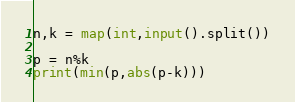Convert code to text. <code><loc_0><loc_0><loc_500><loc_500><_Python_>n,k = map(int,input().split())

p = n%k
print(min(p,abs(p-k)))</code> 